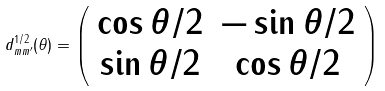Convert formula to latex. <formula><loc_0><loc_0><loc_500><loc_500>d ^ { 1 / 2 } _ { m m ^ { \prime } } ( \theta ) = \left ( \begin{array} { c c } \cos \theta / 2 & - \sin \theta / 2 \\ \sin \theta / 2 & \cos \theta / 2 \end{array} \right )</formula> 